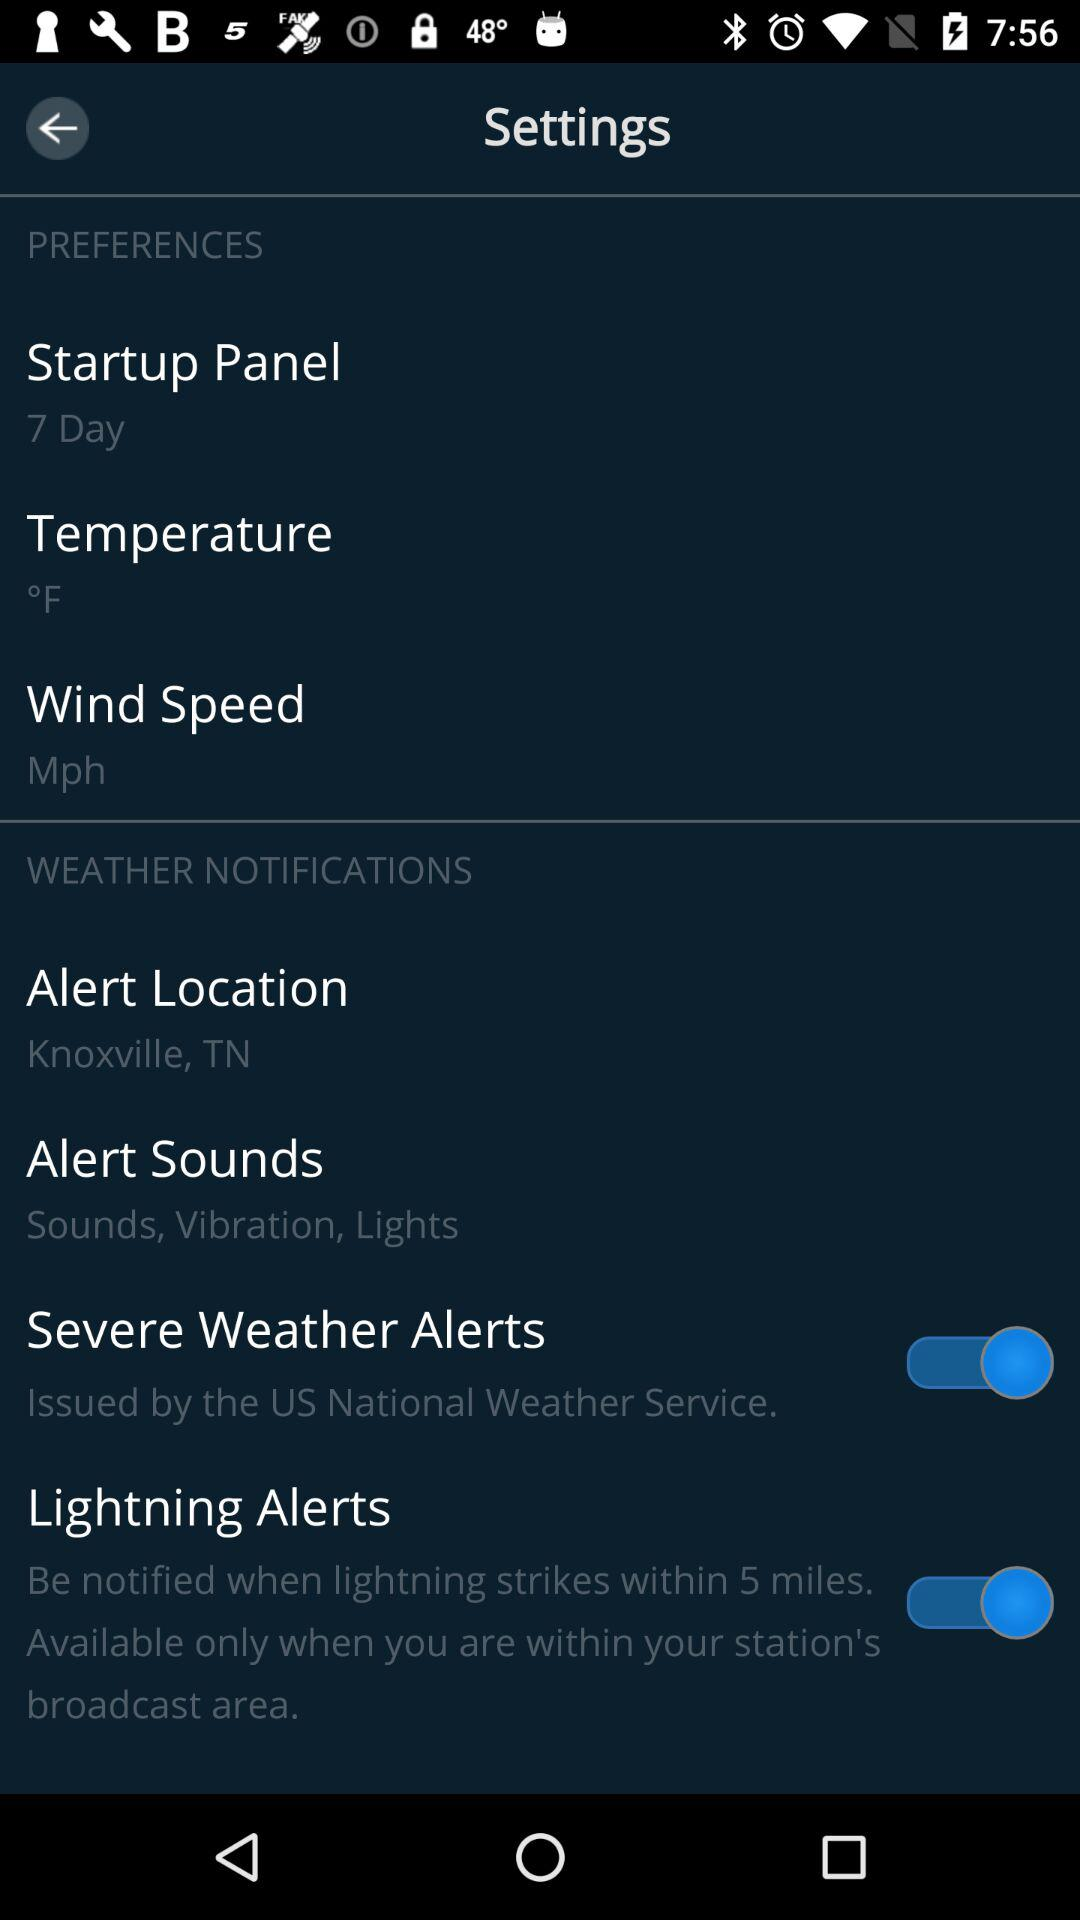What is the setting for "Alert Sounds"? The setting is "Sounds, Vibration, Lights". 